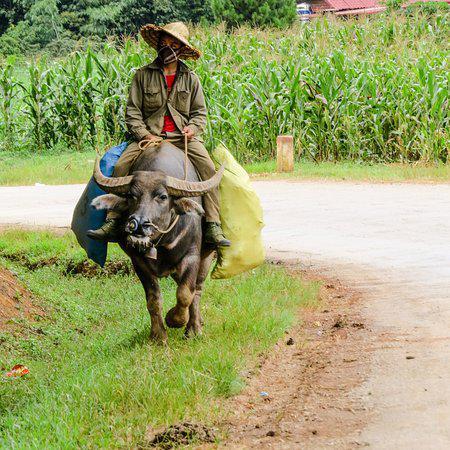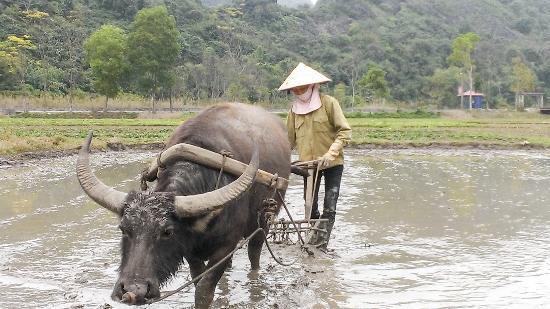The first image is the image on the left, the second image is the image on the right. Examine the images to the left and right. Is the description "The combined images include multiple people wearing hats, multiple water buffalos, and at least one person wearing a hat while on top of a water buffalo." accurate? Answer yes or no. Yes. The first image is the image on the left, the second image is the image on the right. Given the left and right images, does the statement "There is exactly one person sitting on an animal." hold true? Answer yes or no. Yes. 